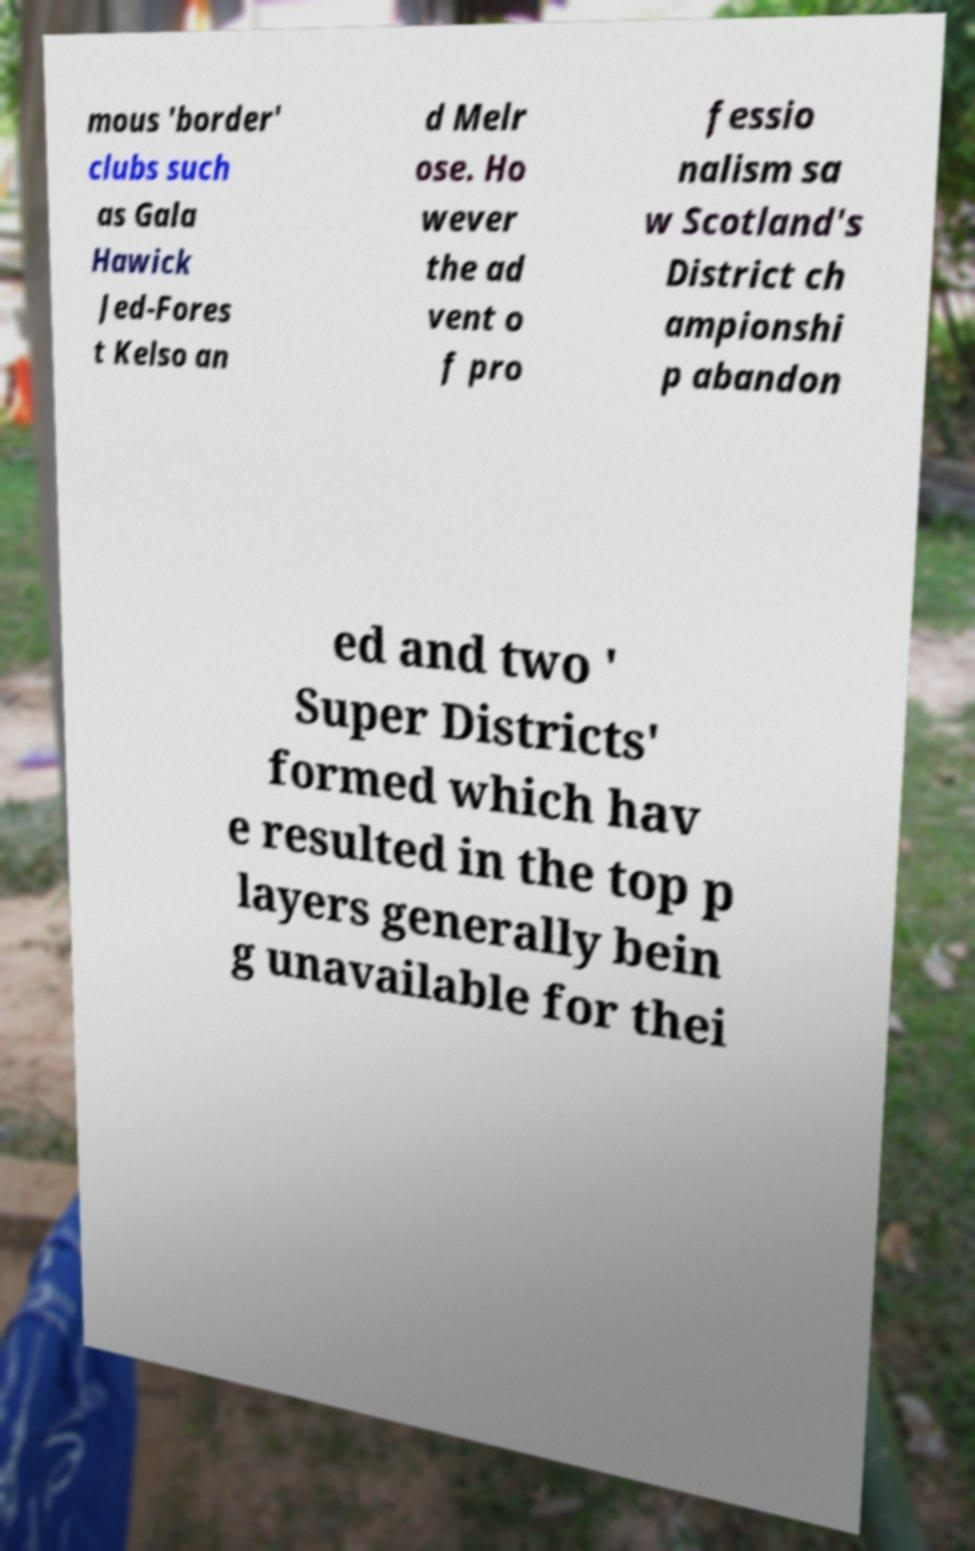Can you accurately transcribe the text from the provided image for me? mous 'border' clubs such as Gala Hawick Jed-Fores t Kelso an d Melr ose. Ho wever the ad vent o f pro fessio nalism sa w Scotland's District ch ampionshi p abandon ed and two ' Super Districts' formed which hav e resulted in the top p layers generally bein g unavailable for thei 